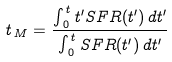Convert formula to latex. <formula><loc_0><loc_0><loc_500><loc_500>t _ { \, M } = \frac { \int _ { \, 0 } ^ { \, t } t ^ { \prime } S F R ( t ^ { \prime } ) \, d t ^ { \prime } } { \int _ { \, 0 } ^ { \, t } S F R ( t ^ { \prime } ) \, d t ^ { \prime } }</formula> 